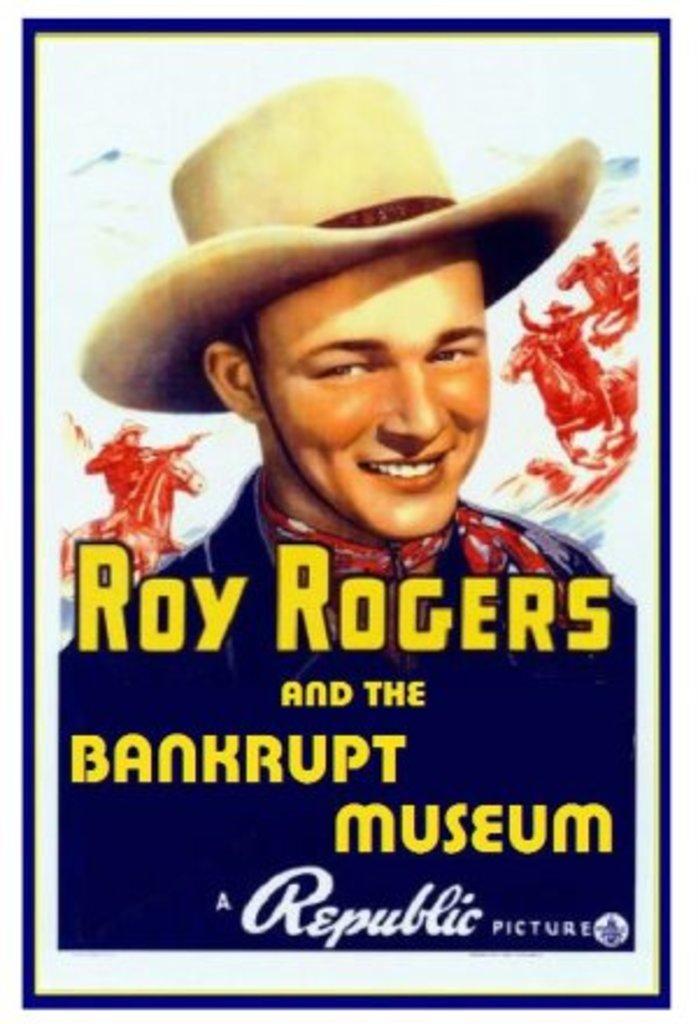What does roy rogers star in?
Give a very brief answer. Bankrupt museum. What company is this produced by?
Offer a very short reply. Republic. 